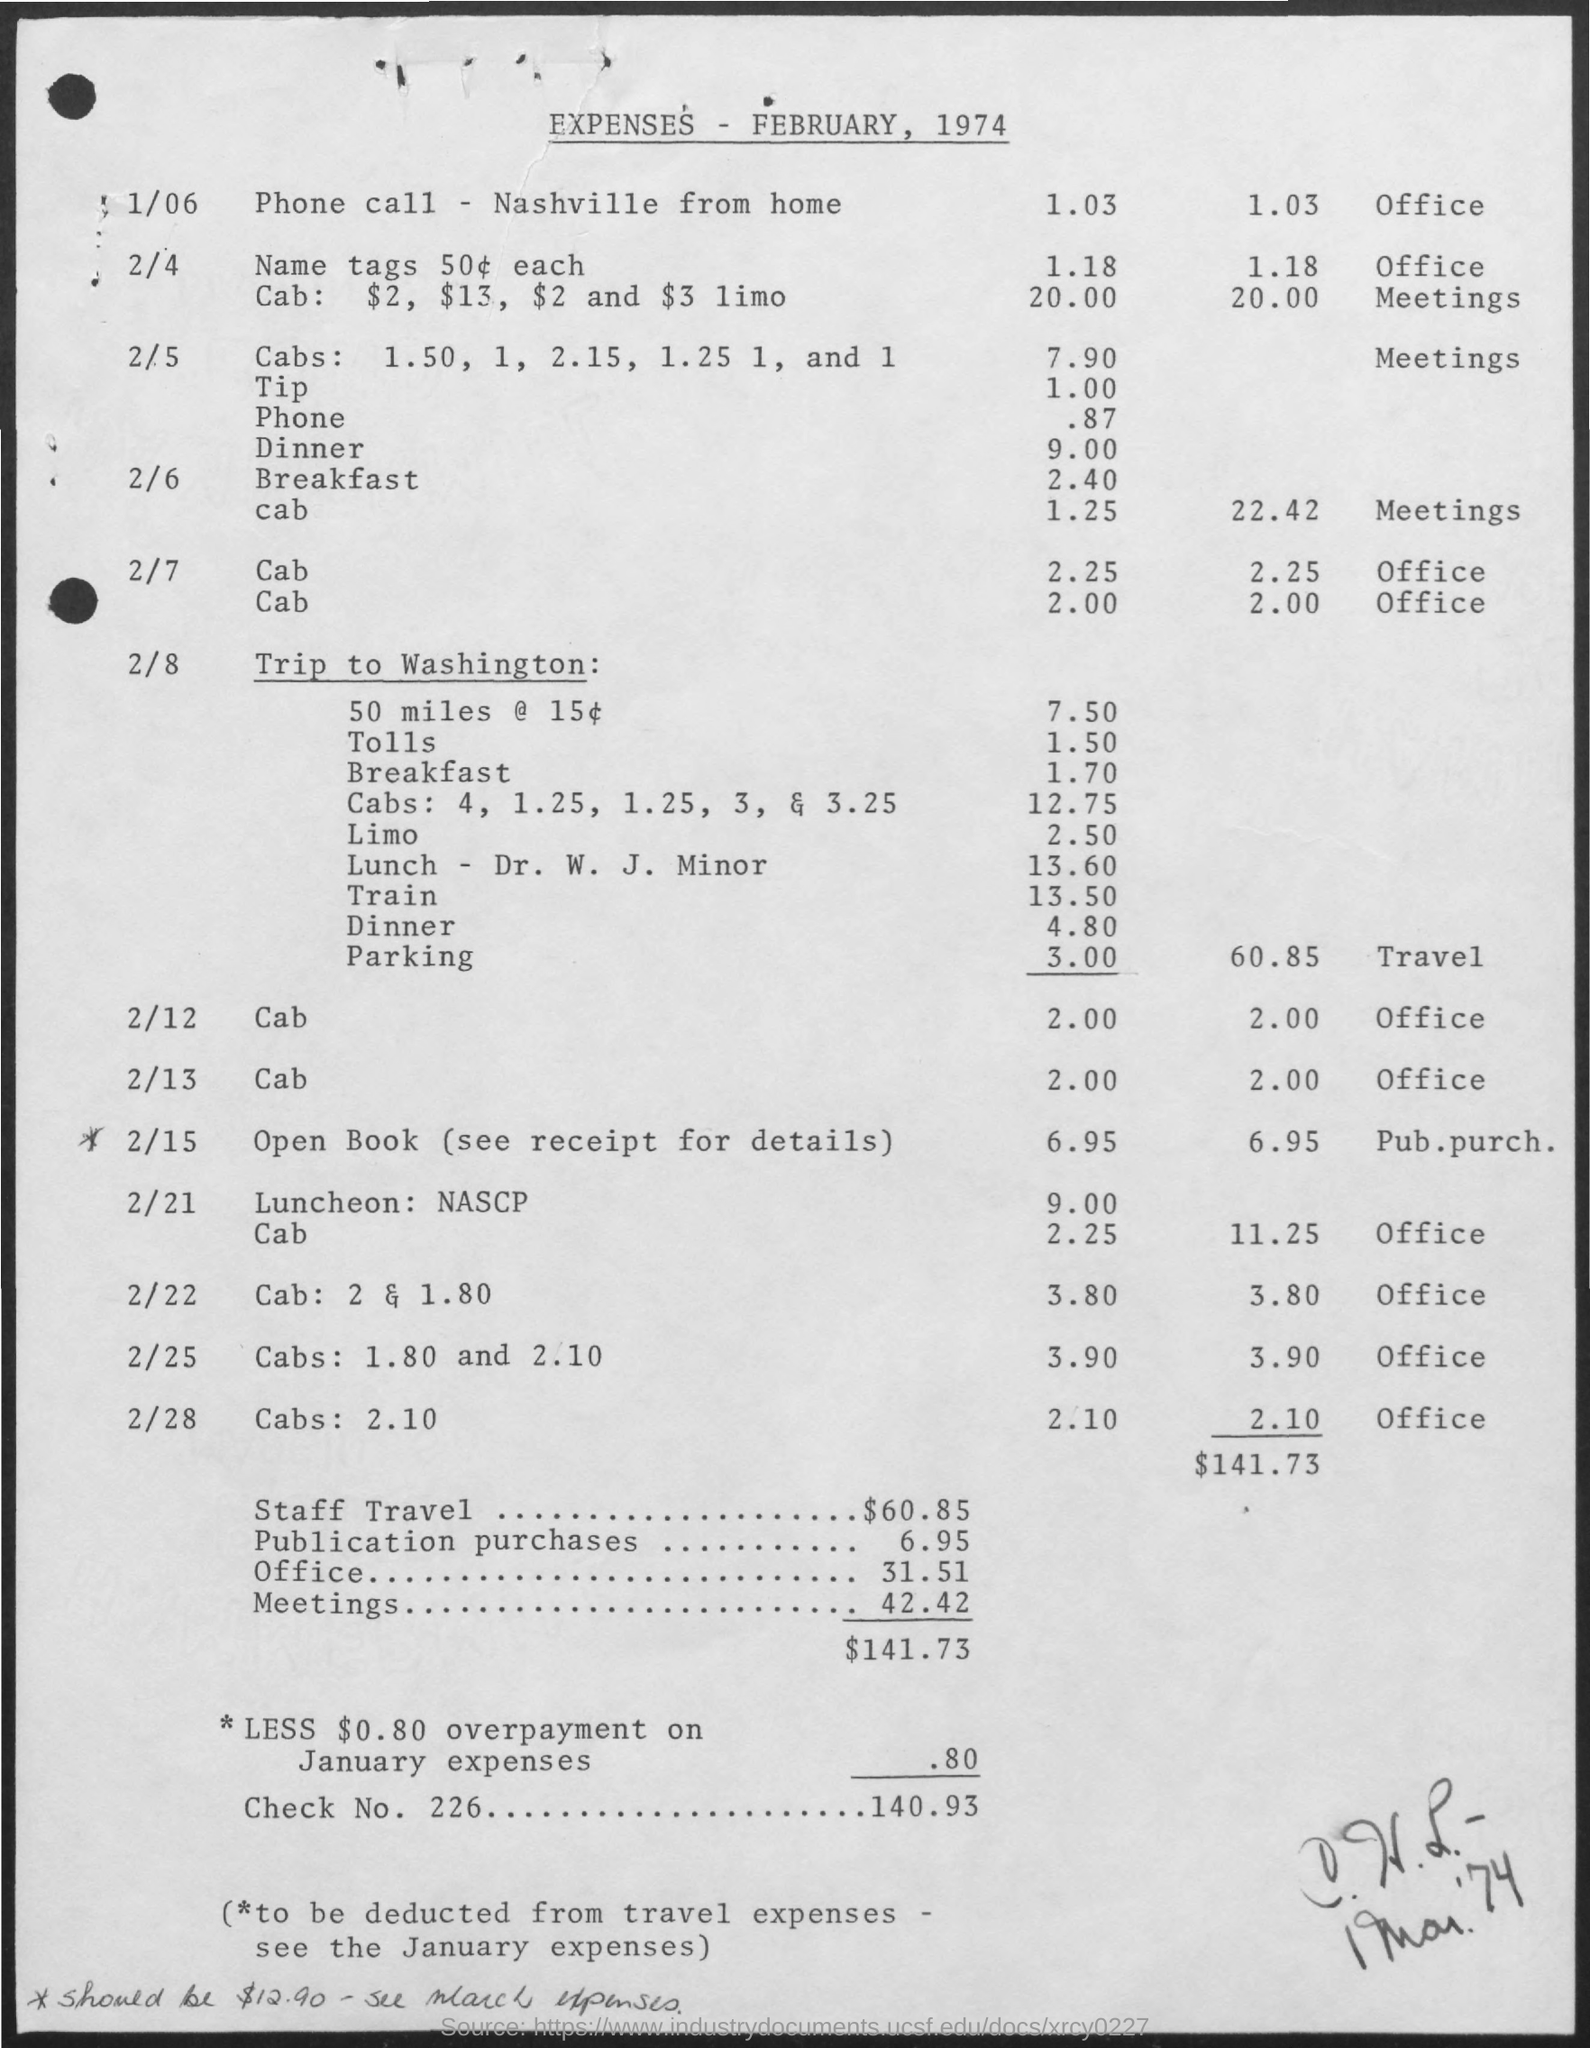What is the document title?
Offer a terse response. Expenses - february, 1974. What is the amount of Check No. 226?
Your answer should be very brief. 140.93. 